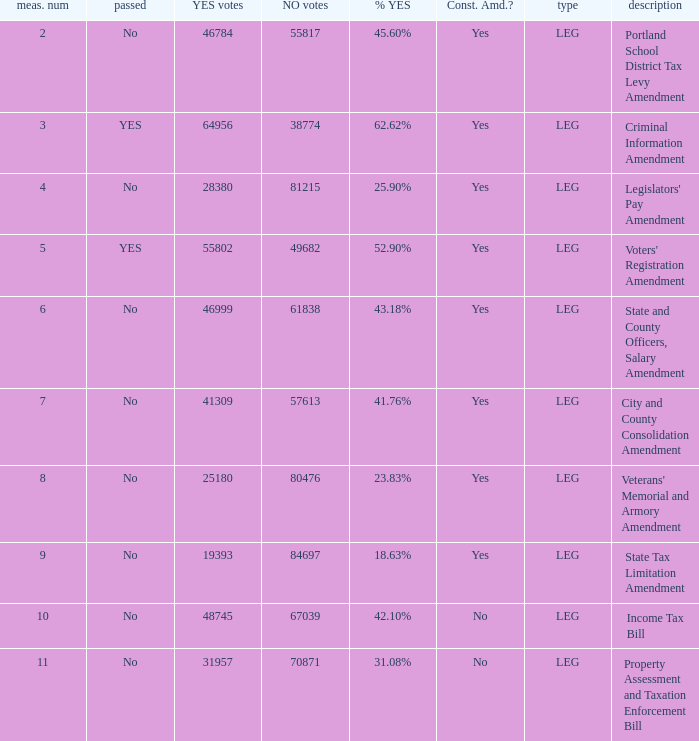Who obtained 4 City and County Consolidation Amendment. 